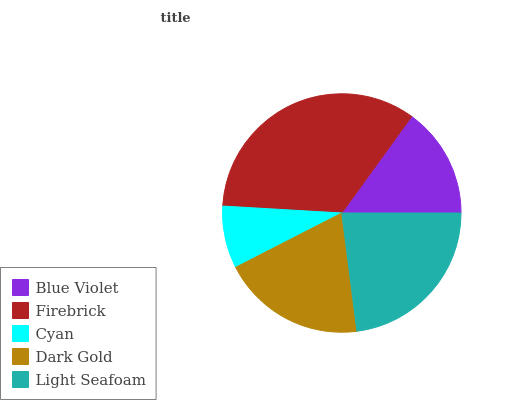Is Cyan the minimum?
Answer yes or no. Yes. Is Firebrick the maximum?
Answer yes or no. Yes. Is Firebrick the minimum?
Answer yes or no. No. Is Cyan the maximum?
Answer yes or no. No. Is Firebrick greater than Cyan?
Answer yes or no. Yes. Is Cyan less than Firebrick?
Answer yes or no. Yes. Is Cyan greater than Firebrick?
Answer yes or no. No. Is Firebrick less than Cyan?
Answer yes or no. No. Is Dark Gold the high median?
Answer yes or no. Yes. Is Dark Gold the low median?
Answer yes or no. Yes. Is Blue Violet the high median?
Answer yes or no. No. Is Light Seafoam the low median?
Answer yes or no. No. 